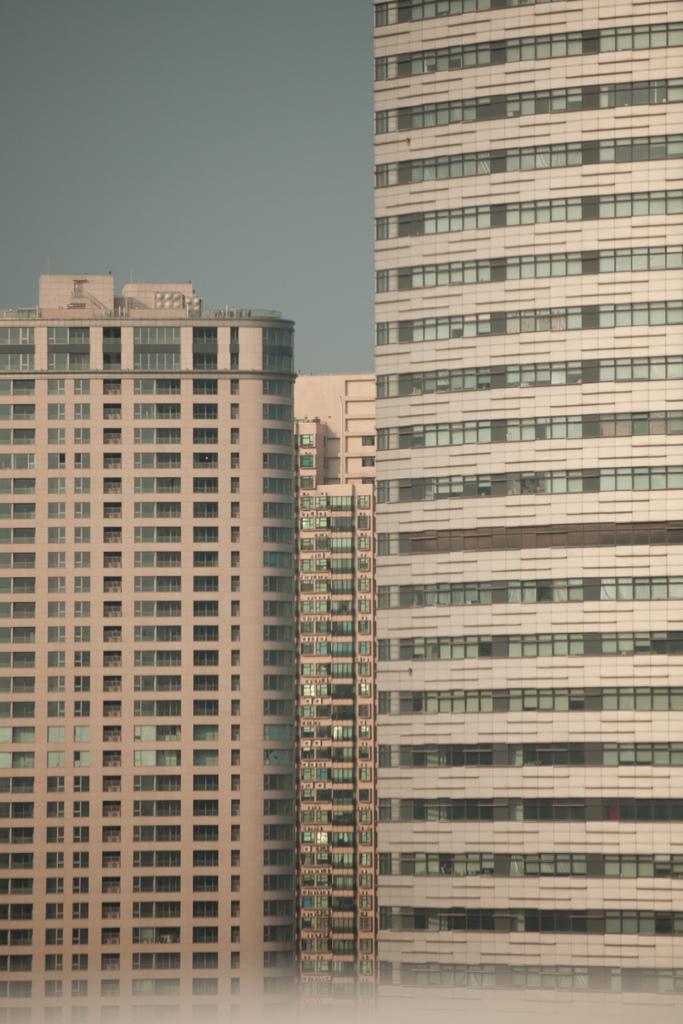Can you describe this image briefly? In this image there are huge buildings and the sky. 